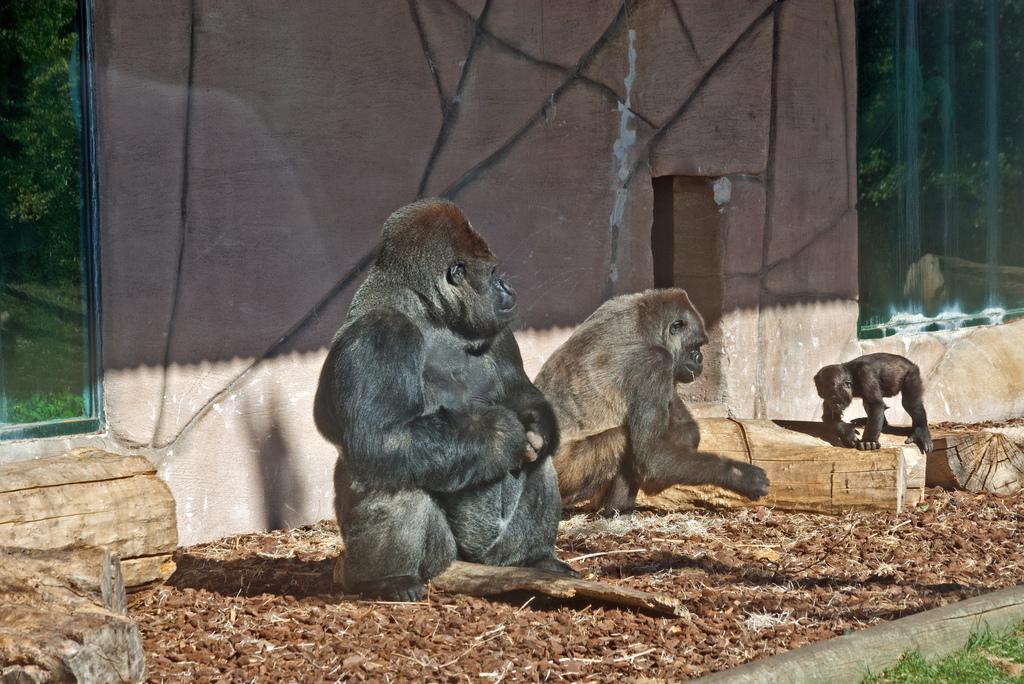Can you describe this image briefly? In this picture we can see animals on the ground, here we can see wooden logs and in the background we can see a wall and some objects. 